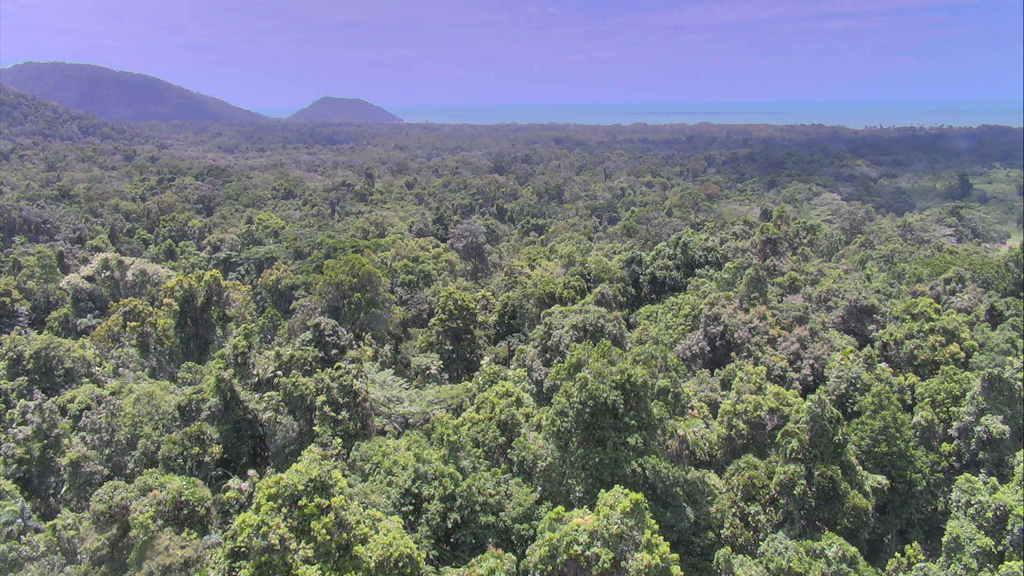What type of vegetation can be seen in the image? There is a group of trees in the image. What geographical features are visible in the image? There are hills visible in the image. What color is the sky in the image? The sky is blue in the image. Where is the secretary located in the image? There is no secretary present in the image; it features a group of trees, hills, and a blue sky. What type of division can be seen in the image? There is no division present in the image; it features a group of trees, hills, and a blue sky. 